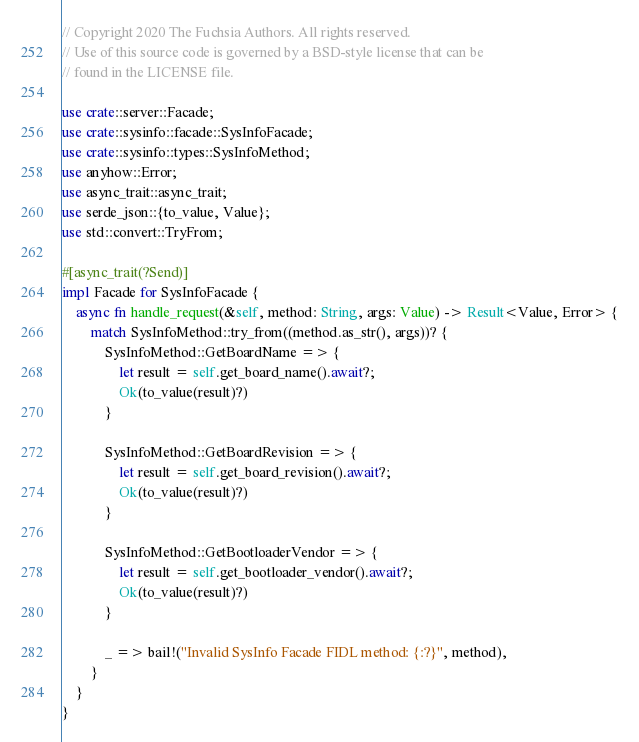Convert code to text. <code><loc_0><loc_0><loc_500><loc_500><_Rust_>// Copyright 2020 The Fuchsia Authors. All rights reserved.
// Use of this source code is governed by a BSD-style license that can be
// found in the LICENSE file.

use crate::server::Facade;
use crate::sysinfo::facade::SysInfoFacade;
use crate::sysinfo::types::SysInfoMethod;
use anyhow::Error;
use async_trait::async_trait;
use serde_json::{to_value, Value};
use std::convert::TryFrom;

#[async_trait(?Send)]
impl Facade for SysInfoFacade {
    async fn handle_request(&self, method: String, args: Value) -> Result<Value, Error> {
        match SysInfoMethod::try_from((method.as_str(), args))? {
            SysInfoMethod::GetBoardName => {
                let result = self.get_board_name().await?;
                Ok(to_value(result)?)
            }

            SysInfoMethod::GetBoardRevision => {
                let result = self.get_board_revision().await?;
                Ok(to_value(result)?)
            }

            SysInfoMethod::GetBootloaderVendor => {
                let result = self.get_bootloader_vendor().await?;
                Ok(to_value(result)?)
            }

            _ => bail!("Invalid SysInfo Facade FIDL method: {:?}", method),
        }
    }
}
</code> 